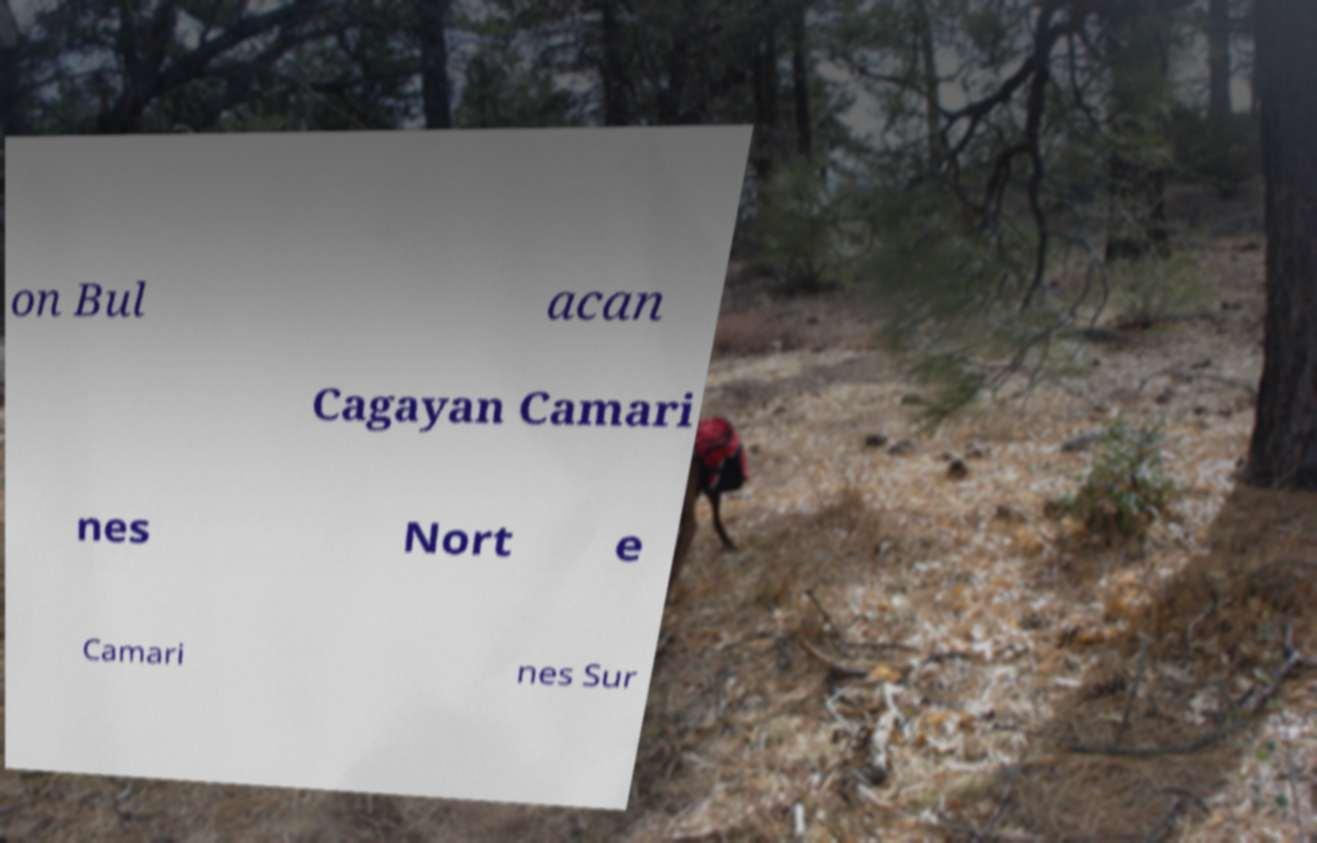Could you extract and type out the text from this image? on Bul acan Cagayan Camari nes Nort e Camari nes Sur 